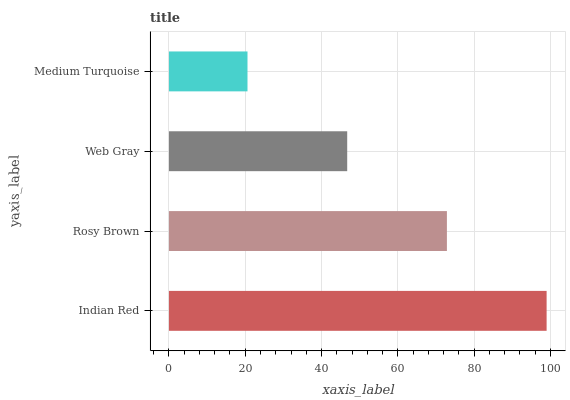Is Medium Turquoise the minimum?
Answer yes or no. Yes. Is Indian Red the maximum?
Answer yes or no. Yes. Is Rosy Brown the minimum?
Answer yes or no. No. Is Rosy Brown the maximum?
Answer yes or no. No. Is Indian Red greater than Rosy Brown?
Answer yes or no. Yes. Is Rosy Brown less than Indian Red?
Answer yes or no. Yes. Is Rosy Brown greater than Indian Red?
Answer yes or no. No. Is Indian Red less than Rosy Brown?
Answer yes or no. No. Is Rosy Brown the high median?
Answer yes or no. Yes. Is Web Gray the low median?
Answer yes or no. Yes. Is Medium Turquoise the high median?
Answer yes or no. No. Is Rosy Brown the low median?
Answer yes or no. No. 